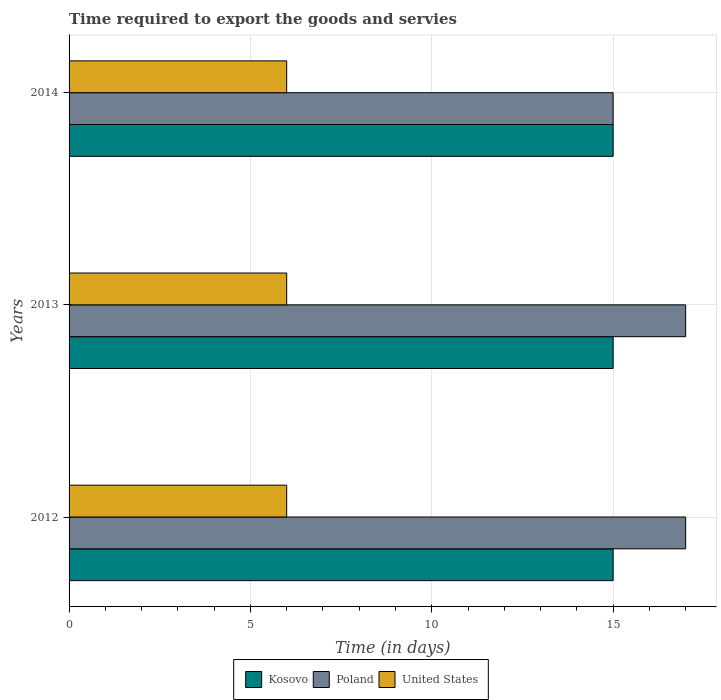How many groups of bars are there?
Offer a very short reply. 3. Are the number of bars on each tick of the Y-axis equal?
Your answer should be very brief. Yes. What is the label of the 3rd group of bars from the top?
Keep it short and to the point. 2012. In how many cases, is the number of bars for a given year not equal to the number of legend labels?
Offer a terse response. 0. In which year was the number of days required to export the goods and services in United States maximum?
Ensure brevity in your answer.  2012. What is the total number of days required to export the goods and services in Poland in the graph?
Ensure brevity in your answer.  49. What is the difference between the number of days required to export the goods and services in Poland in 2012 and that in 2013?
Keep it short and to the point. 0. What is the difference between the number of days required to export the goods and services in Kosovo in 2014 and the number of days required to export the goods and services in Poland in 2013?
Offer a very short reply. -2. What is the average number of days required to export the goods and services in Poland per year?
Keep it short and to the point. 16.33. In the year 2014, what is the difference between the number of days required to export the goods and services in United States and number of days required to export the goods and services in Poland?
Keep it short and to the point. -9. What is the ratio of the number of days required to export the goods and services in Poland in 2012 to that in 2013?
Offer a very short reply. 1. Is the difference between the number of days required to export the goods and services in United States in 2012 and 2013 greater than the difference between the number of days required to export the goods and services in Poland in 2012 and 2013?
Ensure brevity in your answer.  No. What is the difference between the highest and the second highest number of days required to export the goods and services in Poland?
Your response must be concise. 0. What does the 2nd bar from the top in 2014 represents?
Your answer should be very brief. Poland. What does the 1st bar from the bottom in 2013 represents?
Provide a short and direct response. Kosovo. Are all the bars in the graph horizontal?
Your response must be concise. Yes. What is the difference between two consecutive major ticks on the X-axis?
Make the answer very short. 5. Does the graph contain grids?
Provide a short and direct response. Yes. Where does the legend appear in the graph?
Offer a terse response. Bottom center. How are the legend labels stacked?
Keep it short and to the point. Horizontal. What is the title of the graph?
Provide a short and direct response. Time required to export the goods and servies. Does "Cyprus" appear as one of the legend labels in the graph?
Keep it short and to the point. No. What is the label or title of the X-axis?
Provide a short and direct response. Time (in days). What is the Time (in days) in Poland in 2012?
Keep it short and to the point. 17. What is the Time (in days) in Kosovo in 2013?
Provide a succinct answer. 15. What is the Time (in days) of Poland in 2013?
Provide a short and direct response. 17. What is the Time (in days) of United States in 2013?
Keep it short and to the point. 6. Across all years, what is the maximum Time (in days) of United States?
Provide a succinct answer. 6. Across all years, what is the minimum Time (in days) in United States?
Offer a very short reply. 6. What is the total Time (in days) in Poland in the graph?
Your response must be concise. 49. What is the total Time (in days) in United States in the graph?
Provide a succinct answer. 18. What is the difference between the Time (in days) of Kosovo in 2012 and that in 2013?
Your response must be concise. 0. What is the difference between the Time (in days) in Poland in 2012 and that in 2013?
Give a very brief answer. 0. What is the difference between the Time (in days) of Kosovo in 2012 and that in 2014?
Make the answer very short. 0. What is the difference between the Time (in days) of Kosovo in 2013 and that in 2014?
Provide a succinct answer. 0. What is the difference between the Time (in days) of Kosovo in 2012 and the Time (in days) of Poland in 2013?
Offer a terse response. -2. What is the difference between the Time (in days) of Kosovo in 2012 and the Time (in days) of United States in 2013?
Provide a succinct answer. 9. What is the difference between the Time (in days) of Kosovo in 2012 and the Time (in days) of United States in 2014?
Your answer should be compact. 9. What is the difference between the Time (in days) of Poland in 2012 and the Time (in days) of United States in 2014?
Ensure brevity in your answer.  11. What is the difference between the Time (in days) in Kosovo in 2013 and the Time (in days) in Poland in 2014?
Offer a very short reply. 0. What is the average Time (in days) of Kosovo per year?
Make the answer very short. 15. What is the average Time (in days) of Poland per year?
Your answer should be very brief. 16.33. In the year 2012, what is the difference between the Time (in days) of Kosovo and Time (in days) of United States?
Provide a short and direct response. 9. In the year 2012, what is the difference between the Time (in days) of Poland and Time (in days) of United States?
Offer a terse response. 11. In the year 2013, what is the difference between the Time (in days) in Kosovo and Time (in days) in Poland?
Provide a succinct answer. -2. In the year 2013, what is the difference between the Time (in days) in Kosovo and Time (in days) in United States?
Ensure brevity in your answer.  9. In the year 2014, what is the difference between the Time (in days) of Kosovo and Time (in days) of Poland?
Provide a succinct answer. 0. What is the ratio of the Time (in days) of Kosovo in 2012 to that in 2013?
Make the answer very short. 1. What is the ratio of the Time (in days) in Poland in 2012 to that in 2013?
Your response must be concise. 1. What is the ratio of the Time (in days) in Poland in 2012 to that in 2014?
Provide a succinct answer. 1.13. What is the ratio of the Time (in days) of Poland in 2013 to that in 2014?
Offer a terse response. 1.13. What is the difference between the highest and the second highest Time (in days) of Kosovo?
Ensure brevity in your answer.  0. What is the difference between the highest and the second highest Time (in days) in Poland?
Ensure brevity in your answer.  0. What is the difference between the highest and the lowest Time (in days) in Kosovo?
Ensure brevity in your answer.  0. 